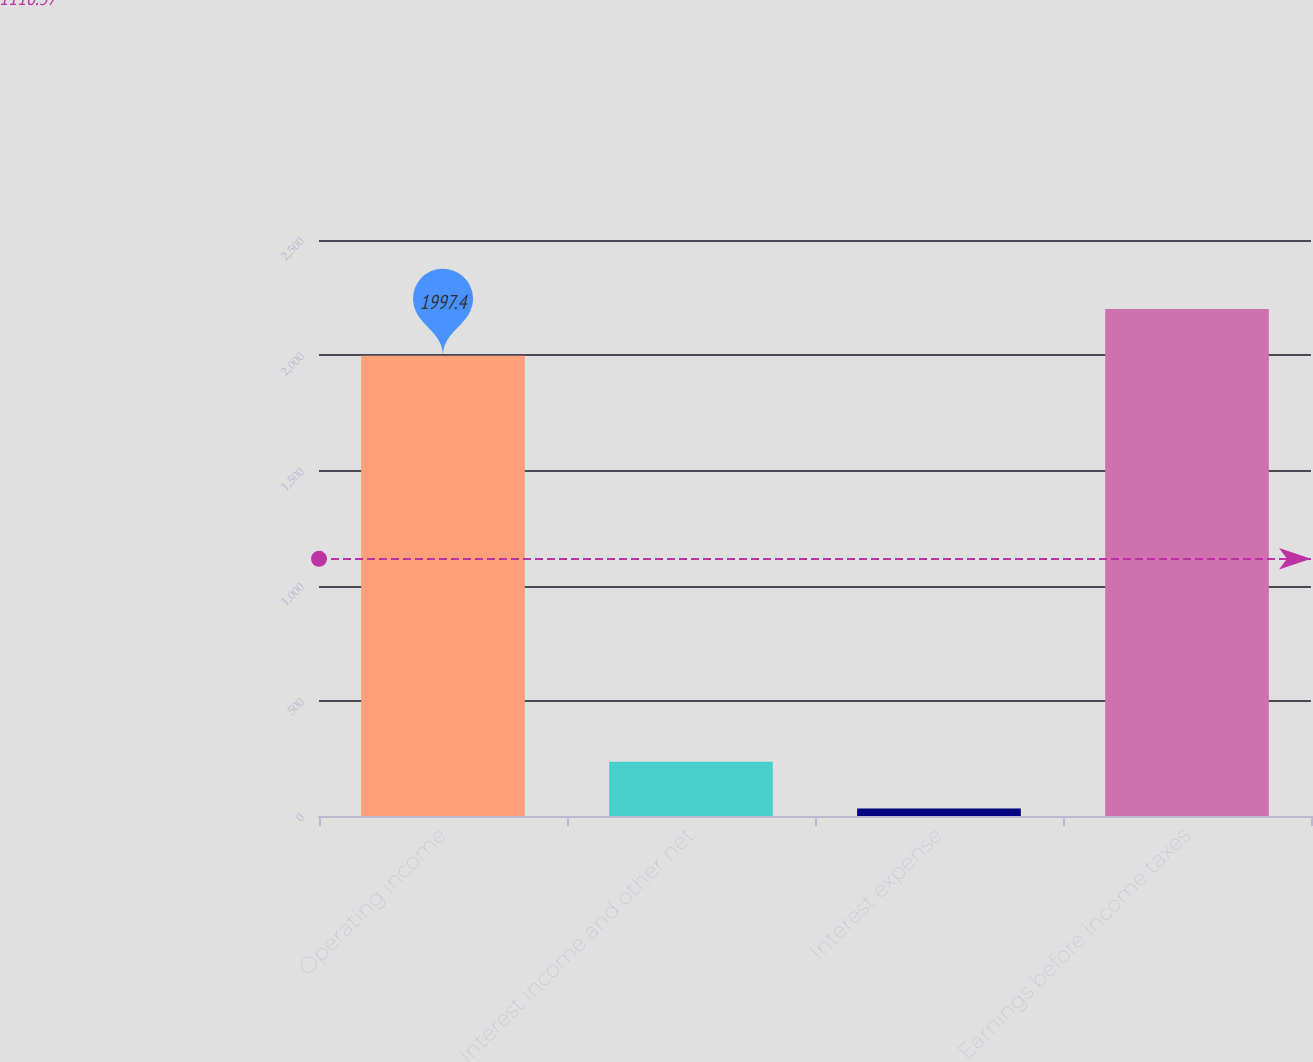Convert chart. <chart><loc_0><loc_0><loc_500><loc_500><bar_chart><fcel>Operating income<fcel>Interest income and other net<fcel>Interest expense<fcel>Earnings before income taxes<nl><fcel>1997.4<fcel>235.34<fcel>32.7<fcel>2200.04<nl></chart> 